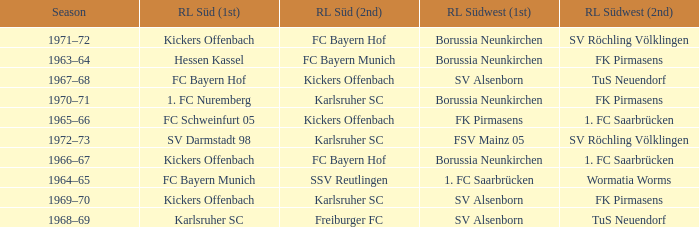Who was RL Süd (1st) when FK Pirmasens was RL Südwest (1st)? FC Schweinfurt 05. 